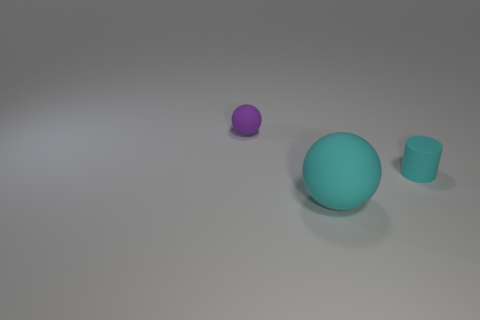Add 3 small matte cylinders. How many objects exist? 6 Subtract all balls. How many objects are left? 1 Subtract 2 spheres. How many spheres are left? 0 Subtract all gray balls. Subtract all yellow blocks. How many balls are left? 2 Subtract all yellow spheres. How many red cylinders are left? 0 Subtract all big cyan things. Subtract all tiny cyan cylinders. How many objects are left? 1 Add 3 matte objects. How many matte objects are left? 6 Add 1 large cyan spheres. How many large cyan spheres exist? 2 Subtract 0 gray blocks. How many objects are left? 3 